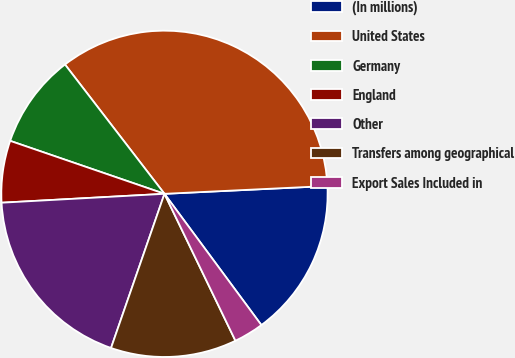Convert chart. <chart><loc_0><loc_0><loc_500><loc_500><pie_chart><fcel>(In millions)<fcel>United States<fcel>Germany<fcel>England<fcel>Other<fcel>Transfers among geographical<fcel>Export Sales Included in<nl><fcel>15.64%<fcel>34.67%<fcel>9.3%<fcel>6.13%<fcel>18.82%<fcel>12.47%<fcel>2.96%<nl></chart> 